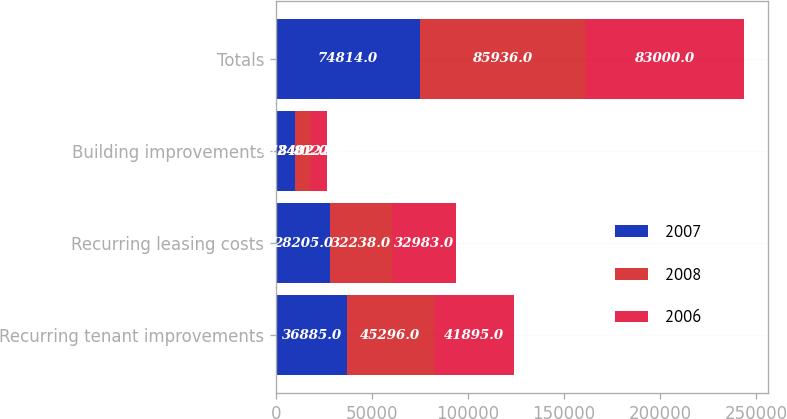Convert chart to OTSL. <chart><loc_0><loc_0><loc_500><loc_500><stacked_bar_chart><ecel><fcel>Recurring tenant improvements<fcel>Recurring leasing costs<fcel>Building improvements<fcel>Totals<nl><fcel>2007<fcel>36885<fcel>28205<fcel>9724<fcel>74814<nl><fcel>2008<fcel>45296<fcel>32238<fcel>8402<fcel>85936<nl><fcel>2006<fcel>41895<fcel>32983<fcel>8122<fcel>83000<nl></chart> 